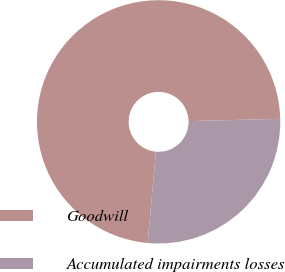<chart> <loc_0><loc_0><loc_500><loc_500><pie_chart><fcel>Goodwill<fcel>Accumulated impairments losses<nl><fcel>73.17%<fcel>26.83%<nl></chart> 